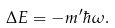Convert formula to latex. <formula><loc_0><loc_0><loc_500><loc_500>\Delta E = - m ^ { \prime } \hbar { \omega } .</formula> 